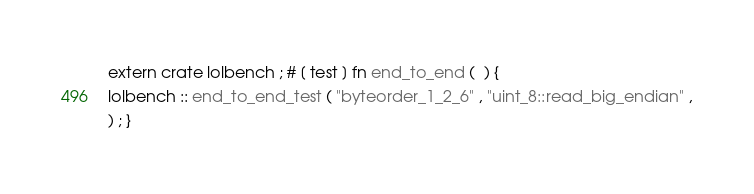<code> <loc_0><loc_0><loc_500><loc_500><_Rust_>extern crate lolbench ; # [ test ] fn end_to_end (  ) {
lolbench :: end_to_end_test ( "byteorder_1_2_6" , "uint_8::read_big_endian" ,
) ; }</code> 